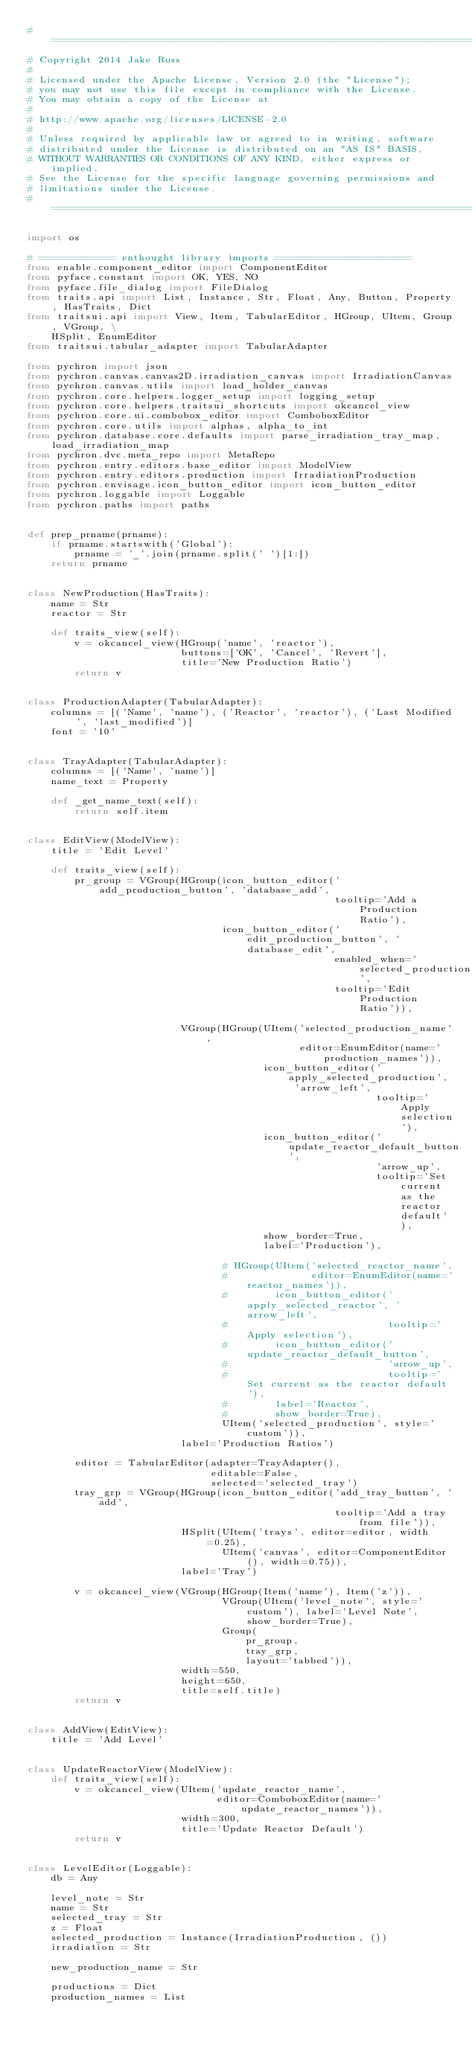Convert code to text. <code><loc_0><loc_0><loc_500><loc_500><_Python_># ===============================================================================
# Copyright 2014 Jake Ross
#
# Licensed under the Apache License, Version 2.0 (the "License");
# you may not use this file except in compliance with the License.
# You may obtain a copy of the License at
#
# http://www.apache.org/licenses/LICENSE-2.0
#
# Unless required by applicable law or agreed to in writing, software
# distributed under the License is distributed on an "AS IS" BASIS,
# WITHOUT WARRANTIES OR CONDITIONS OF ANY KIND, either express or implied.
# See the License for the specific language governing permissions and
# limitations under the License.
# ===============================================================================

import os

# ============= enthought library imports =======================
from enable.component_editor import ComponentEditor
from pyface.constant import OK, YES, NO
from pyface.file_dialog import FileDialog
from traits.api import List, Instance, Str, Float, Any, Button, Property, HasTraits, Dict
from traitsui.api import View, Item, TabularEditor, HGroup, UItem, Group, VGroup, \
    HSplit, EnumEditor
from traitsui.tabular_adapter import TabularAdapter

from pychron import json
from pychron.canvas.canvas2D.irradiation_canvas import IrradiationCanvas
from pychron.canvas.utils import load_holder_canvas
from pychron.core.helpers.logger_setup import logging_setup
from pychron.core.helpers.traitsui_shortcuts import okcancel_view
from pychron.core.ui.combobox_editor import ComboboxEditor
from pychron.core.utils import alphas, alpha_to_int
from pychron.database.core.defaults import parse_irradiation_tray_map, load_irradiation_map
from pychron.dvc.meta_repo import MetaRepo
from pychron.entry.editors.base_editor import ModelView
from pychron.entry.editors.production import IrradiationProduction
from pychron.envisage.icon_button_editor import icon_button_editor
from pychron.loggable import Loggable
from pychron.paths import paths


def prep_prname(prname):
    if prname.startswith('Global'):
        prname = '_'.join(prname.split(' ')[1:])
    return prname


class NewProduction(HasTraits):
    name = Str
    reactor = Str

    def traits_view(self):
        v = okcancel_view(HGroup('name', 'reactor'),
                          buttons=['OK', 'Cancel', 'Revert'],
                          title='New Production Ratio')
        return v


class ProductionAdapter(TabularAdapter):
    columns = [('Name', 'name'), ('Reactor', 'reactor'), ('Last Modified', 'last_modified')]
    font = '10'


class TrayAdapter(TabularAdapter):
    columns = [('Name', 'name')]
    name_text = Property

    def _get_name_text(self):
        return self.item


class EditView(ModelView):
    title = 'Edit Level'

    def traits_view(self):
        pr_group = VGroup(HGroup(icon_button_editor('add_production_button', 'database_add',
                                                    tooltip='Add a Production Ratio'),
                                 icon_button_editor('edit_production_button', 'database_edit',
                                                    enabled_when='selected_production',
                                                    tooltip='Edit Production Ratio')),

                          VGroup(HGroup(UItem('selected_production_name',
                                              editor=EnumEditor(name='production_names')),
                                        icon_button_editor('apply_selected_production', 'arrow_left',
                                                           tooltip='Apply selection'),
                                        icon_button_editor('update_reactor_default_button',
                                                           'arrow_up',
                                                           tooltip='Set current as the reactor default'),
                                        show_border=True,
                                        label='Production'),

                                 # HGroup(UItem('selected_reactor_name',
                                 #              editor=EnumEditor(name='reactor_names')),
                                 #        icon_button_editor('apply_selected_reactor', 'arrow_left',
                                 #                           tooltip='Apply selection'),
                                 #        icon_button_editor('update_reactor_default_button',
                                 #                           'arrow_up',
                                 #                           tooltip='Set current as the reactor default'),
                                 #        label='Reactor',
                                 #        show_border=True),
                                 UItem('selected_production', style='custom')),
                          label='Production Ratios')

        editor = TabularEditor(adapter=TrayAdapter(),
                               editable=False,
                               selected='selected_tray')
        tray_grp = VGroup(HGroup(icon_button_editor('add_tray_button', 'add',
                                                    tooltip='Add a tray from file')),
                          HSplit(UItem('trays', editor=editor, width=0.25),
                                 UItem('canvas', editor=ComponentEditor(), width=0.75)),
                          label='Tray')

        v = okcancel_view(VGroup(HGroup(Item('name'), Item('z')),
                                 VGroup(UItem('level_note', style='custom'), label='Level Note', show_border=True),
                                 Group(
                                     pr_group,
                                     tray_grp,
                                     layout='tabbed')),
                          width=550,
                          height=650,
                          title=self.title)
        return v


class AddView(EditView):
    title = 'Add Level'


class UpdateReactorView(ModelView):
    def traits_view(self):
        v = okcancel_view(UItem('update_reactor_name',
                                editor=ComboboxEditor(name='update_reactor_names')),
                          width=300,
                          title='Update Reactor Default')
        return v


class LevelEditor(Loggable):
    db = Any

    level_note = Str
    name = Str
    selected_tray = Str
    z = Float
    selected_production = Instance(IrradiationProduction, ())
    irradiation = Str

    new_production_name = Str

    productions = Dict
    production_names = List</code> 